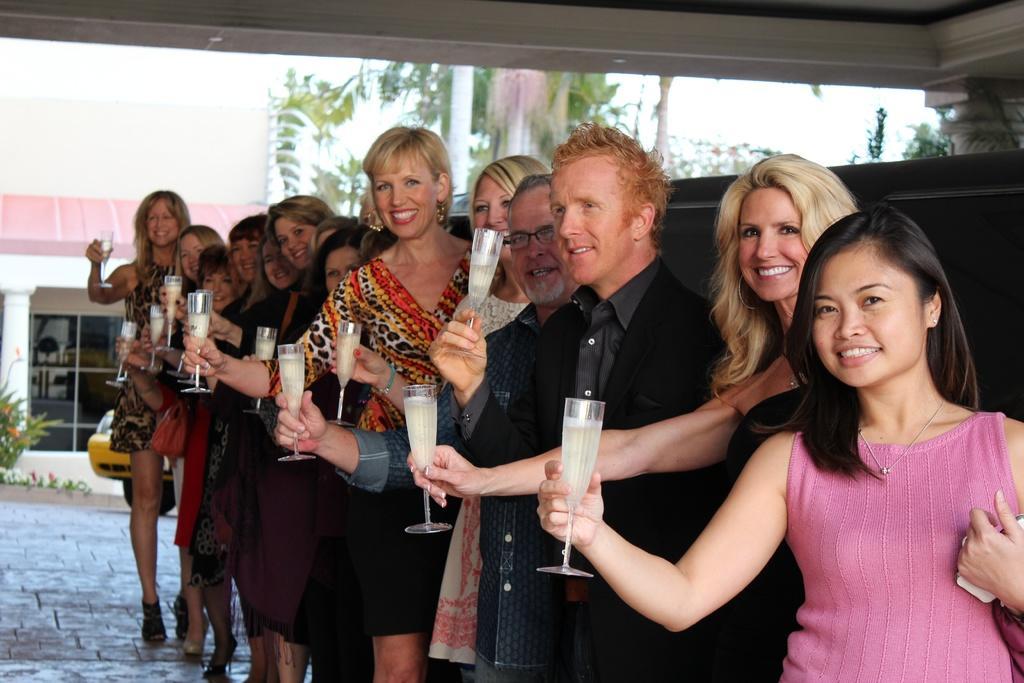Could you give a brief overview of what you see in this image? In this image I can see two men and I can see number of women are standing. I can see all of them are holding glasses and I can see smile on their faces. In background I can see trees, a building, a plant and a yellow colour vehicle. 